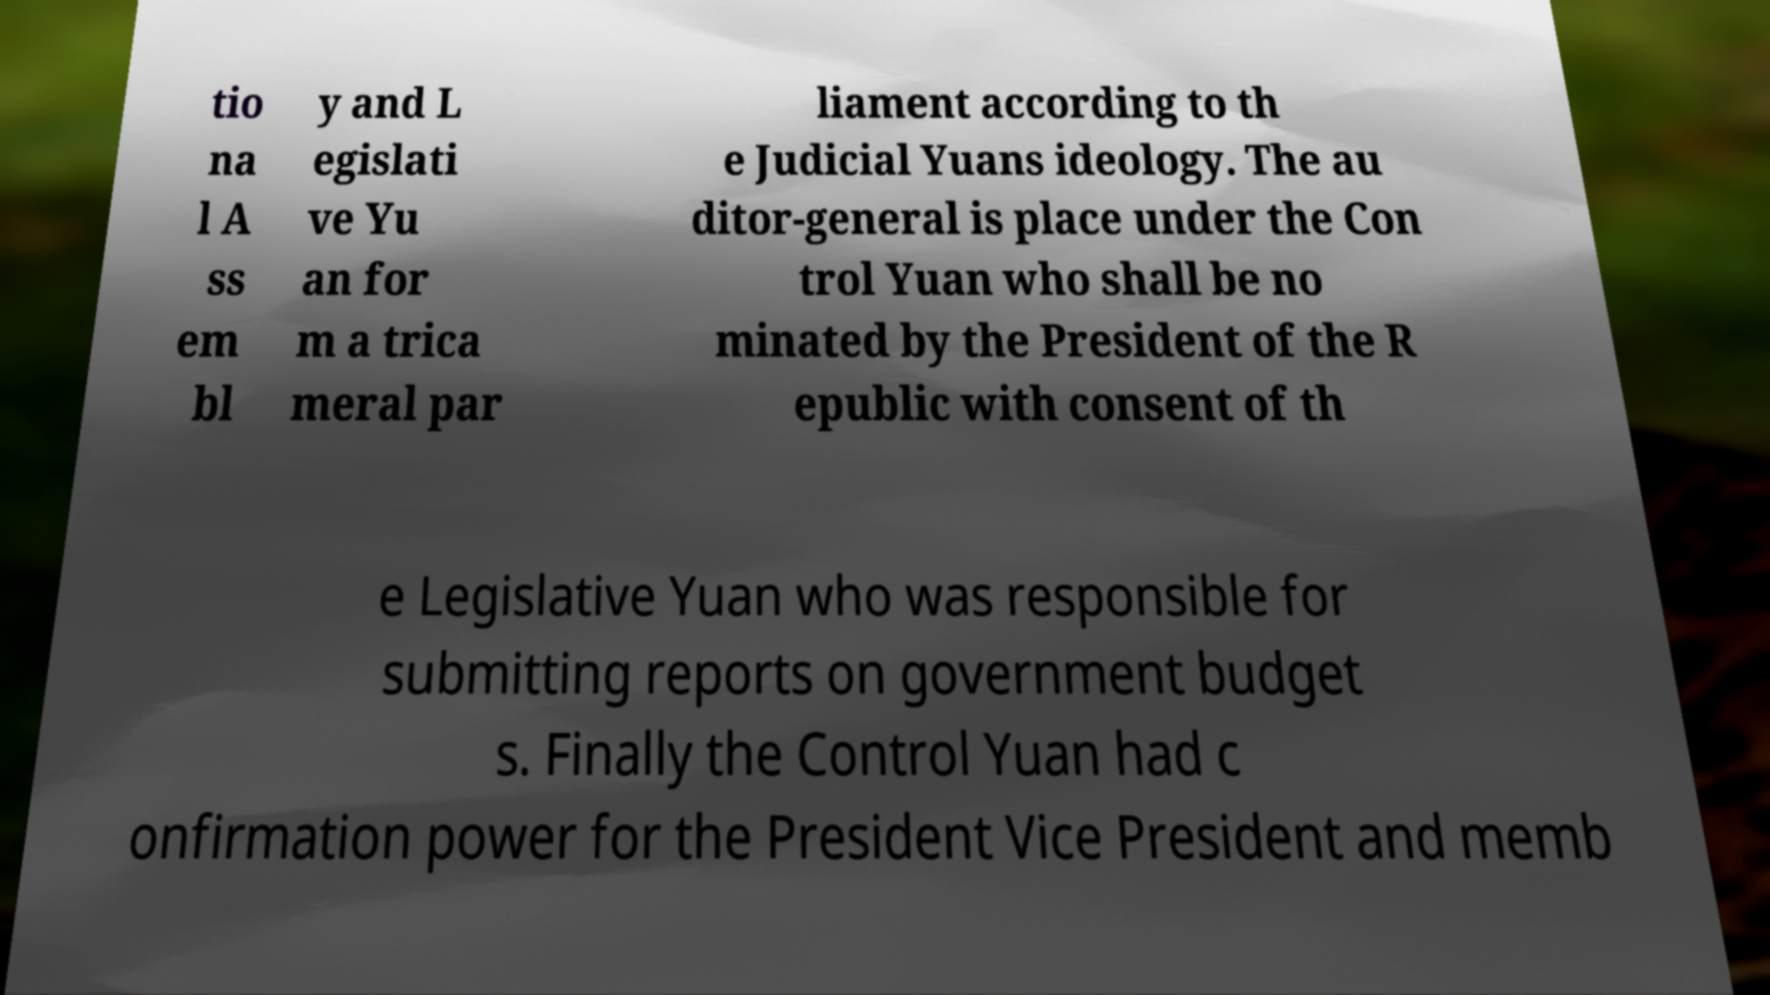For documentation purposes, I need the text within this image transcribed. Could you provide that? tio na l A ss em bl y and L egislati ve Yu an for m a trica meral par liament according to th e Judicial Yuans ideology. The au ditor-general is place under the Con trol Yuan who shall be no minated by the President of the R epublic with consent of th e Legislative Yuan who was responsible for submitting reports on government budget s. Finally the Control Yuan had c onfirmation power for the President Vice President and memb 